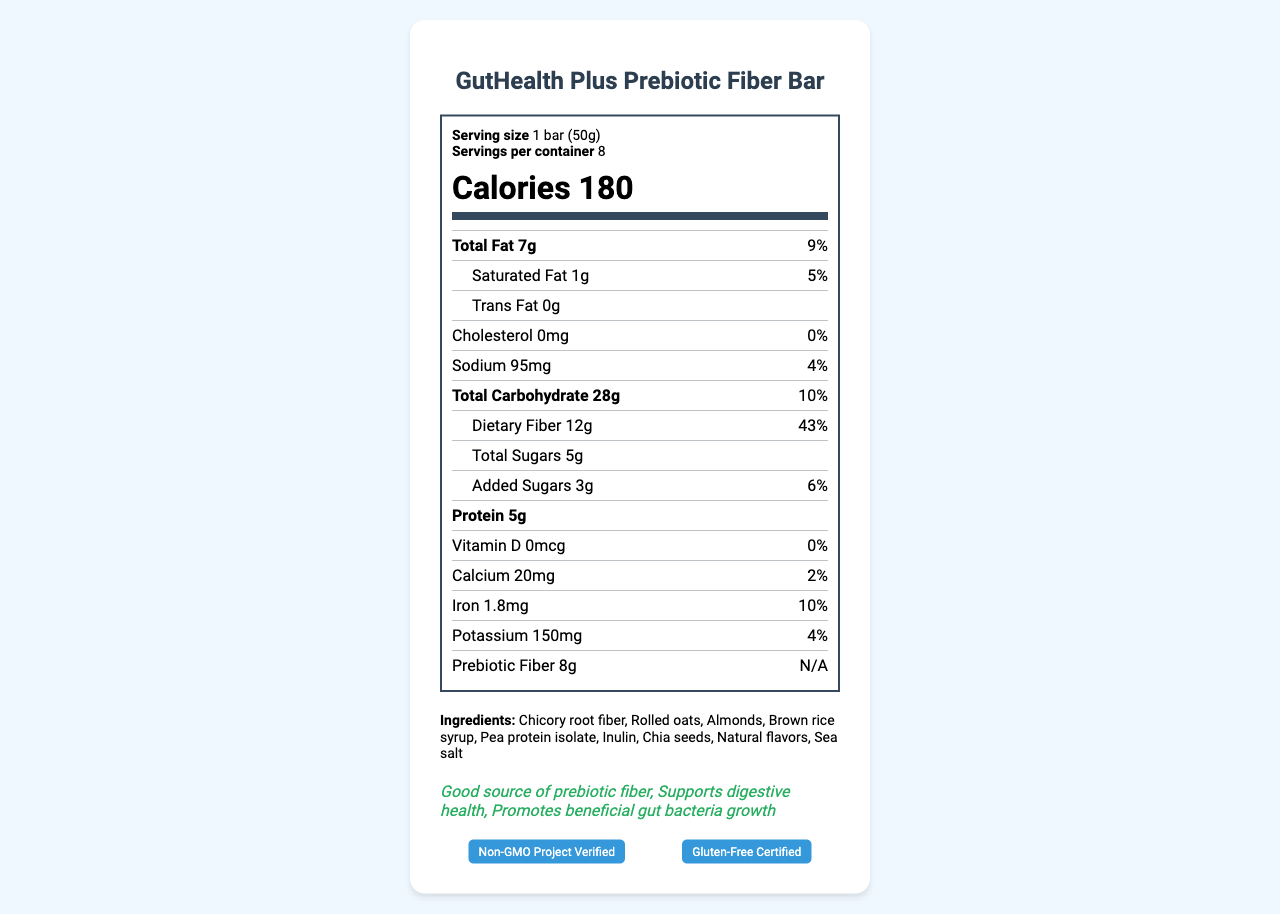what is the serving size of the GutHealth Plus Prebiotic Fiber Bar? The serving size information is listed under the serving info section at the top of the Nutrition Facts Label.
Answer: 1 bar (50g) how many servings are there per container? This is found under the serving info section, which indicates the number of servings per container.
Answer: 8 what are the total calories per serving? The total calories per serving is clearly displayed under the calories section in large, bold font.
Answer: 180 how much dietary fiber is in one serving of the GutHealth Plus Prebiotic Fiber Bar? The amount of dietary fiber per serving is mentioned under the total carbohydrate section.
Answer: 12g what is the percentage daily value of iron in this product? This is listed under the iron section with its corresponding daily value.
Answer: 10% what ingredient is listed first in the GutHealth Plus Prebiotic Fiber Bar? The first ingredient listed is always the one with the highest quantity in the product, found under the ingredients section.
Answer: Chicory root fiber what are some health claims made by the GutHealth Plus Prebiotic Fiber Bar? These claims are highlighted in the health claims section.
Answer: Good source of prebiotic fiber, Supports digestive health, Promotes beneficial gut bacteria growth which nutrient does the product contain in the highest quantity: Sodium, Potassium, or Calcium? A. Sodium B. Potassium C. Calcium Sodium has 95mg, Potassium has 150mg, and Calcium has 20mg; thus, Sodium has the highest quantity.
Answer: A. Sodium how much added sugar is in one serving of the GutHealth Plus Prebiotic Fiber Bar? The amount of added sugars is listed under the total sugars section.
Answer: 3g is this product gluten-free? The product is indicated as gluten-free under the certifications section, showing "Gluten-Free Certified."
Answer: Yes does the product contain any allergens? The allergen information states that the product contains almonds and may contain traces of peanuts and other tree nuts.
Answer: Yes summarize the main information presented in the Nutrition Facts Label of the GutHealth Plus Prebiotic Fiber Bar. The document provides a detailed breakdown of the nutritional content, ingredients, health benefits, certifications, and additional information about the product and its usage.
Answer: The GutHealth Plus Prebiotic Fiber Bar contains 180 calories per 50g serving with significant dietary fiber (12g) and prebiotic fiber (8g) content. It is designed to support gut health by promoting beneficial gut bacteria growth. It includes ingredients like chicory root fiber, rolled oats, and almonds and is free from GMOs and gluten. The product is manufactured by NutriWell Foods, Inc. and contains health claims supporting digestive health. Allergen information and storage instructions are also provided. what is the main source of prebiotic fiber in this product? While chicory root fiber and inulin are known prebiotic fibers listed as ingredients, the document does not specify which ingredient is the primary source of the prebiotic fiber mentioned.
Answer: Cannot be determined 